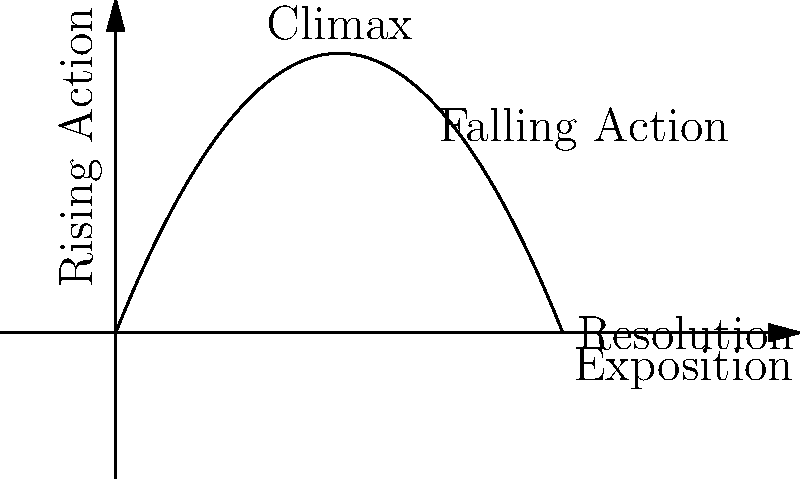Analyze the plot diagram above, which represents the narrative structure of a novel. What literary element is missing from this representation, and how would its inclusion enhance students' understanding of story structure? 1. Observe the plot diagram: It shows the basic elements of narrative structure including exposition, rising action, climax, falling action, and resolution.

2. Identify the missing element: The diagram lacks a representation of conflict, which is a crucial component of narrative structure.

3. Understand the importance of conflict: Conflict drives the plot, creates tension, and motivates character actions.

4. Consider how conflict relates to other elements: Conflict typically emerges during the exposition, intensifies through rising action, reaches its peak at the climax, and is resolved during falling action.

5. Visualize the enhancement: Including conflict would show students how it interacts with and shapes other narrative elements throughout the story.

6. Reflect on pedagogical value: Adding conflict to the diagram would provide a more comprehensive view of story structure, helping students better analyze and understand narratives.
Answer: Conflict; its inclusion would illustrate how tension drives plot development and character growth throughout the narrative. 